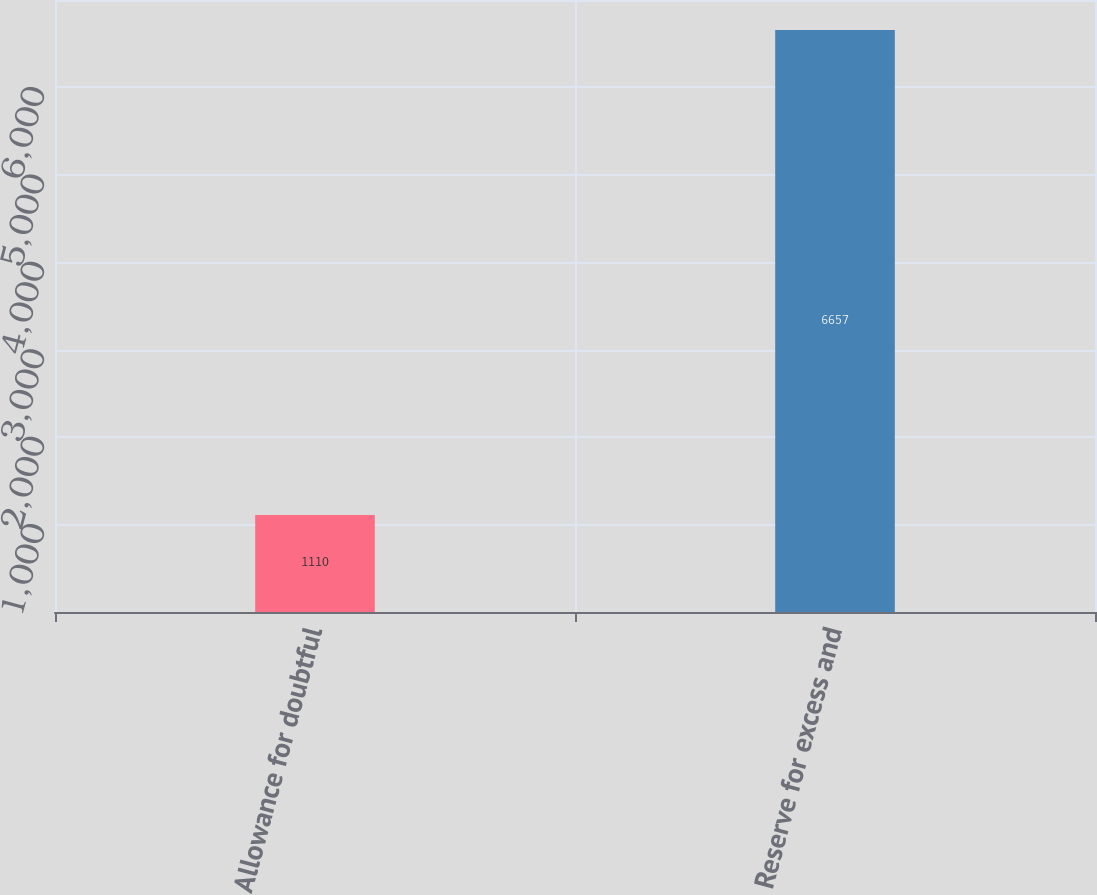Convert chart. <chart><loc_0><loc_0><loc_500><loc_500><bar_chart><fcel>Allowance for doubtful<fcel>Reserve for excess and<nl><fcel>1110<fcel>6657<nl></chart> 